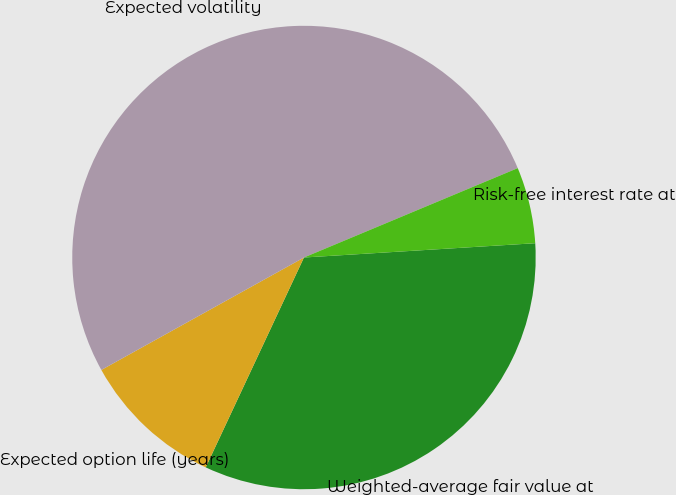<chart> <loc_0><loc_0><loc_500><loc_500><pie_chart><fcel>Weighted-average fair value at<fcel>Expected option life (years)<fcel>Expected volatility<fcel>Risk-free interest rate at<nl><fcel>32.95%<fcel>9.97%<fcel>51.76%<fcel>5.32%<nl></chart> 